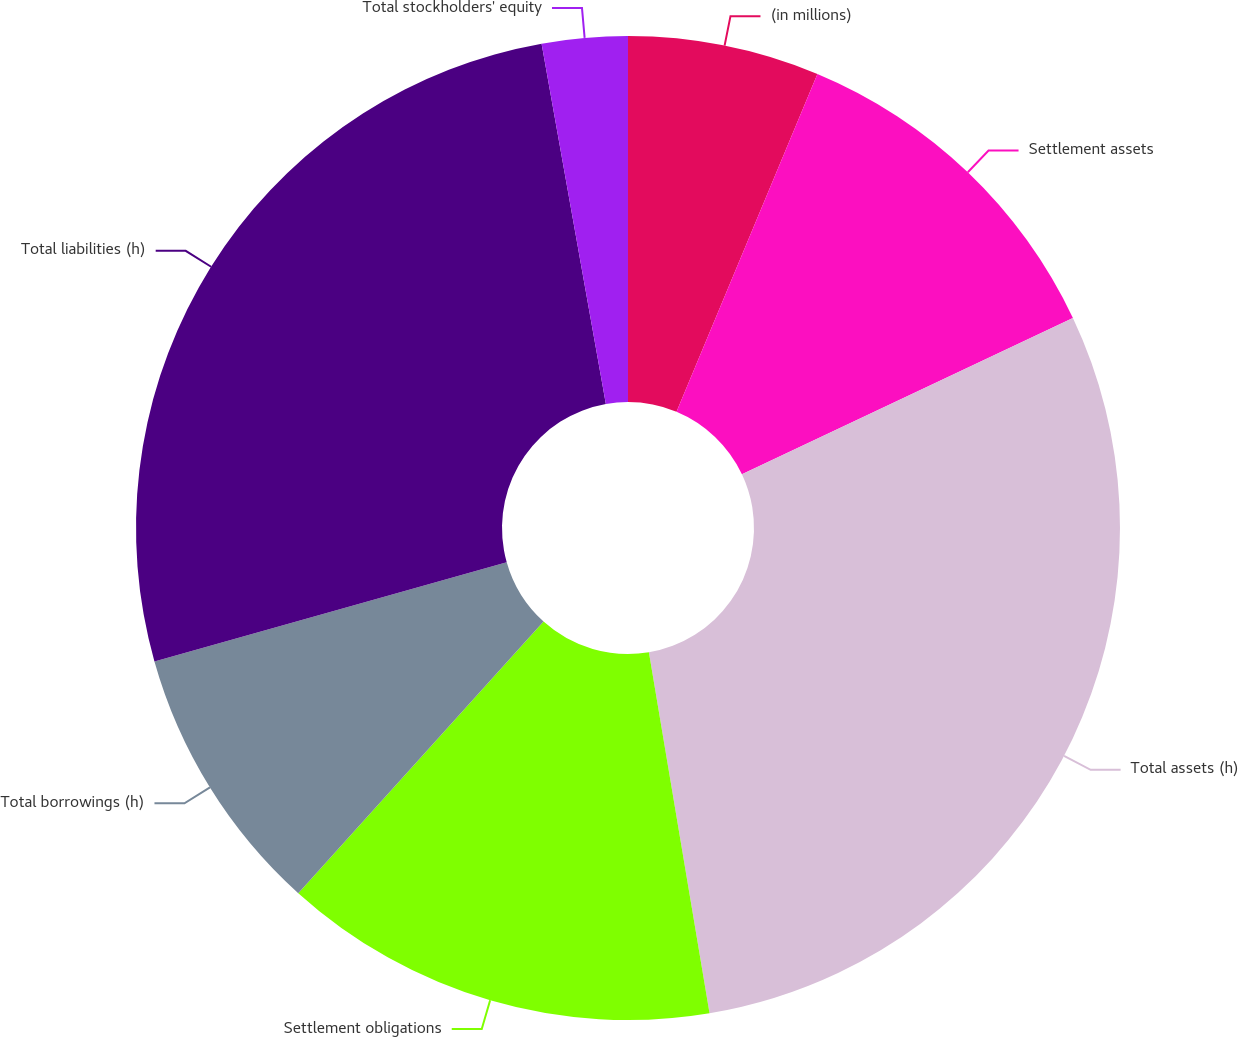Convert chart to OTSL. <chart><loc_0><loc_0><loc_500><loc_500><pie_chart><fcel>(in millions)<fcel>Settlement assets<fcel>Total assets (h)<fcel>Settlement obligations<fcel>Total borrowings (h)<fcel>Total liabilities (h)<fcel>Total stockholders' equity<nl><fcel>6.29%<fcel>11.69%<fcel>29.37%<fcel>14.34%<fcel>8.94%<fcel>26.56%<fcel>2.81%<nl></chart> 